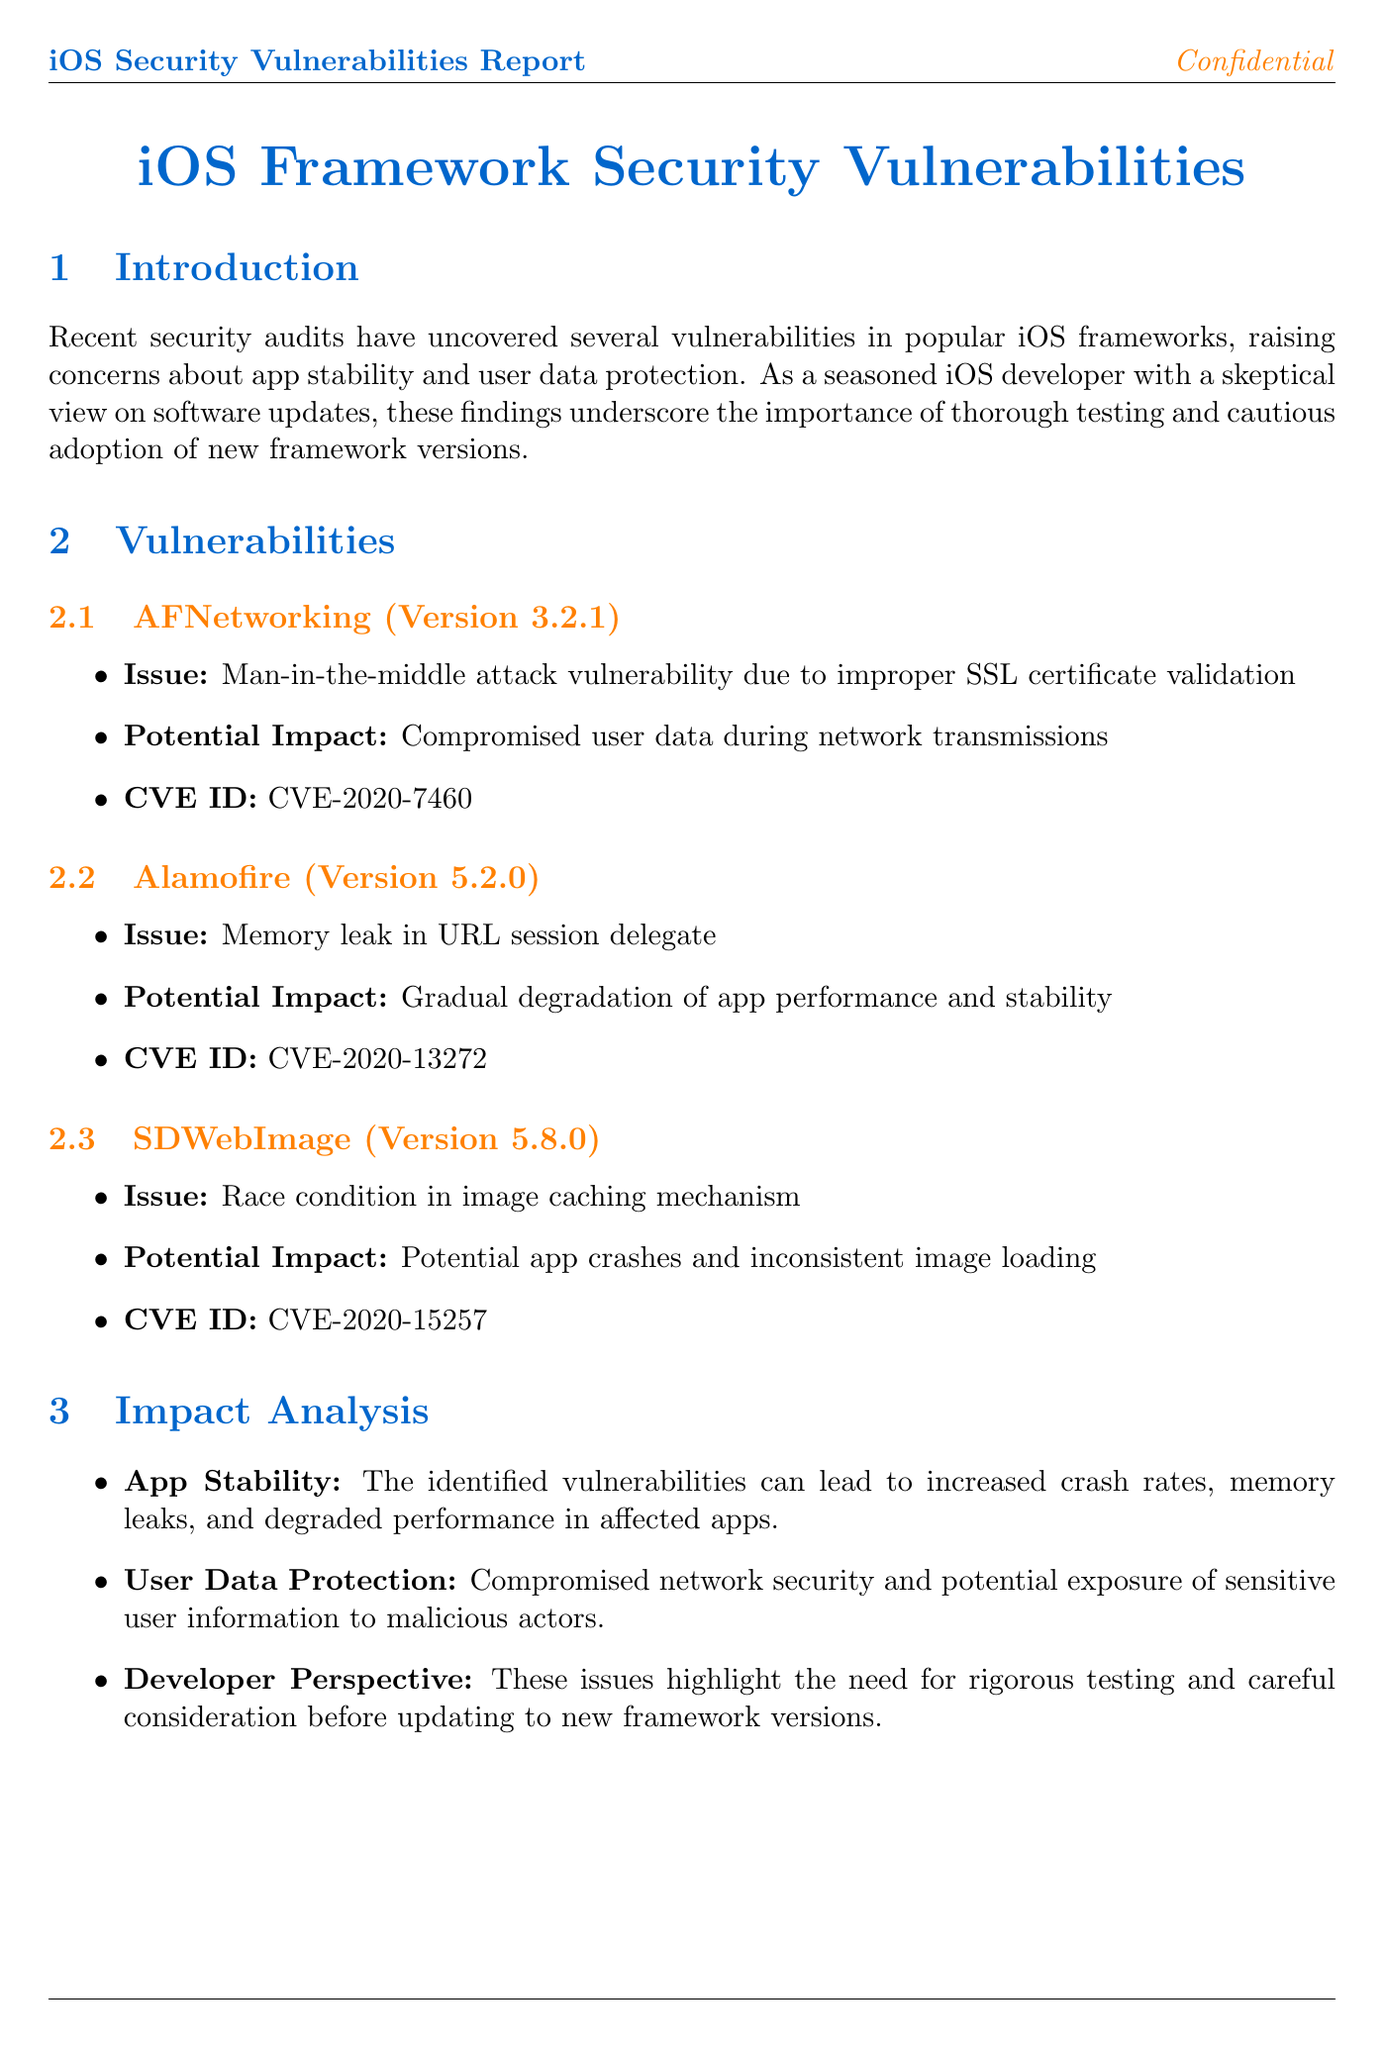What is the CVE ID for AFNetworking? The CVE ID indicates the specific ID for tracking vulnerabilities, which for AFNetworking is listed as CVE-2020-7460.
Answer: CVE-2020-7460 What version of Alamofire is affected? The document specifies that Alamofire version 5.2.0 is the one affected by the memory leak vulnerability.
Answer: 5.2.0 What is the potential impact of the vulnerability in SDWebImage? The potential impact describes that there could be app crashes and inconsistent image loading due to the identified race condition.
Answer: Potential app crashes and inconsistent image loading What is one mitigation strategy suggested in the document? The document lists multiple mitigation strategies, one of which includes implementing thorough security testing for all third-party frameworks.
Answer: Implement thorough security testing for all third-party frameworks Who has acknowledged the reported vulnerabilities? The document states that Apple has acknowledged the vulnerabilities and is addressing them with framework maintainers.
Answer: Apple What is the main concern raised in the introduction? The introduction indicates that vulnerabilities affect app stability and user data protection, which is the primary concern highlighted.
Answer: App stability and user data protection What is the recommendation for developers from the conclusion? The conclusion advises developers to approach framework updates cautiously and thoroughly test their implementations to mitigate risk.
Answer: Approach framework updates with caution What framework has a man-in-the-middle attack vulnerability? The document identifies AFNetworking as having a man-in-the-middle attack vulnerability due to improper SSL certificate validation.
Answer: AFNetworking What does the developer perspective section emphasize? It emphasizes the need for rigorous testing and careful consideration before updating to new framework versions due to identified issues.
Answer: Need for rigorous testing and careful consideration 